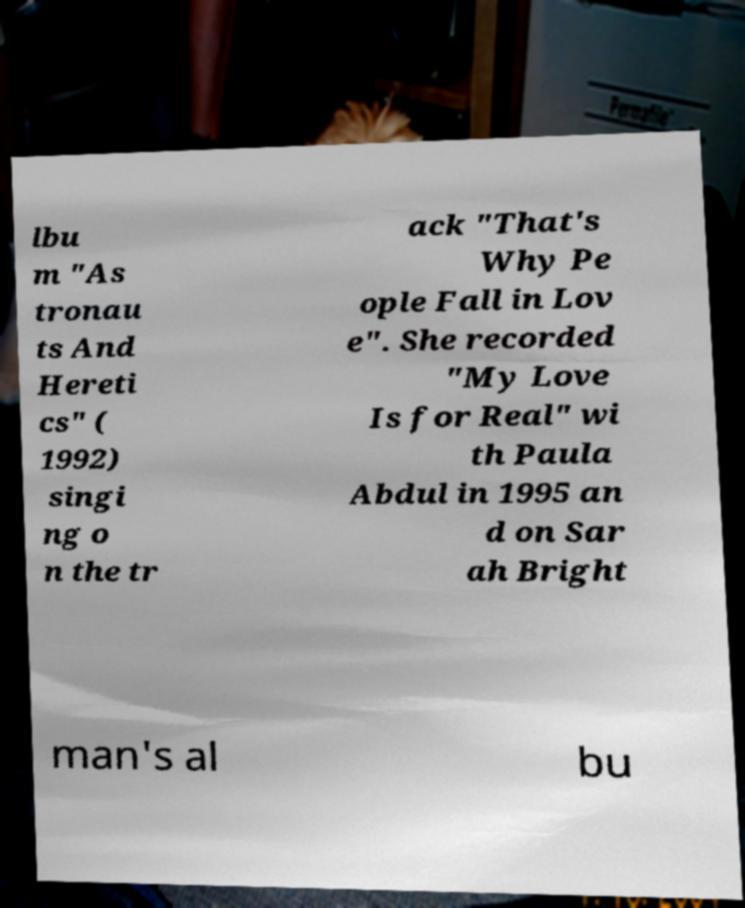Could you extract and type out the text from this image? lbu m "As tronau ts And Hereti cs" ( 1992) singi ng o n the tr ack "That's Why Pe ople Fall in Lov e". She recorded "My Love Is for Real" wi th Paula Abdul in 1995 an d on Sar ah Bright man's al bu 